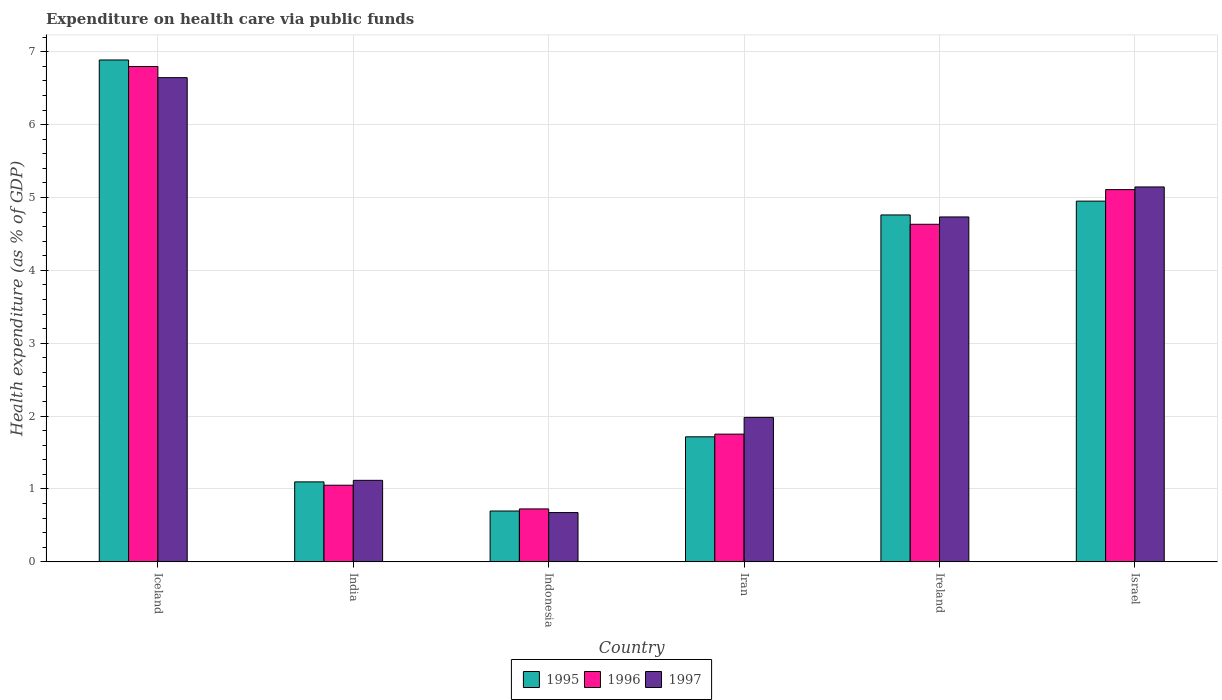How many different coloured bars are there?
Your answer should be very brief. 3. How many groups of bars are there?
Provide a short and direct response. 6. Are the number of bars per tick equal to the number of legend labels?
Keep it short and to the point. Yes. Are the number of bars on each tick of the X-axis equal?
Make the answer very short. Yes. How many bars are there on the 2nd tick from the left?
Your answer should be compact. 3. How many bars are there on the 6th tick from the right?
Offer a very short reply. 3. What is the label of the 5th group of bars from the left?
Your answer should be very brief. Ireland. What is the expenditure made on health care in 1997 in India?
Keep it short and to the point. 1.12. Across all countries, what is the maximum expenditure made on health care in 1995?
Keep it short and to the point. 6.89. Across all countries, what is the minimum expenditure made on health care in 1997?
Ensure brevity in your answer.  0.68. In which country was the expenditure made on health care in 1996 maximum?
Your response must be concise. Iceland. In which country was the expenditure made on health care in 1995 minimum?
Make the answer very short. Indonesia. What is the total expenditure made on health care in 1995 in the graph?
Your answer should be very brief. 20.11. What is the difference between the expenditure made on health care in 1996 in India and that in Indonesia?
Provide a short and direct response. 0.33. What is the difference between the expenditure made on health care in 1996 in Ireland and the expenditure made on health care in 1995 in Indonesia?
Your answer should be very brief. 3.93. What is the average expenditure made on health care in 1997 per country?
Keep it short and to the point. 3.38. What is the difference between the expenditure made on health care of/in 1996 and expenditure made on health care of/in 1995 in Indonesia?
Your answer should be very brief. 0.03. In how many countries, is the expenditure made on health care in 1997 greater than 2.4 %?
Ensure brevity in your answer.  3. What is the ratio of the expenditure made on health care in 1997 in Iran to that in Ireland?
Make the answer very short. 0.42. What is the difference between the highest and the second highest expenditure made on health care in 1997?
Ensure brevity in your answer.  -0.41. What is the difference between the highest and the lowest expenditure made on health care in 1995?
Your answer should be very brief. 6.19. In how many countries, is the expenditure made on health care in 1997 greater than the average expenditure made on health care in 1997 taken over all countries?
Offer a very short reply. 3. Is the sum of the expenditure made on health care in 1995 in India and Indonesia greater than the maximum expenditure made on health care in 1997 across all countries?
Provide a short and direct response. No. Is it the case that in every country, the sum of the expenditure made on health care in 1995 and expenditure made on health care in 1996 is greater than the expenditure made on health care in 1997?
Your answer should be very brief. Yes. How many bars are there?
Make the answer very short. 18. How many countries are there in the graph?
Your answer should be very brief. 6. Are the values on the major ticks of Y-axis written in scientific E-notation?
Give a very brief answer. No. Does the graph contain any zero values?
Make the answer very short. No. Does the graph contain grids?
Make the answer very short. Yes. Where does the legend appear in the graph?
Provide a succinct answer. Bottom center. How are the legend labels stacked?
Your answer should be compact. Horizontal. What is the title of the graph?
Offer a terse response. Expenditure on health care via public funds. What is the label or title of the X-axis?
Make the answer very short. Country. What is the label or title of the Y-axis?
Give a very brief answer. Health expenditure (as % of GDP). What is the Health expenditure (as % of GDP) of 1995 in Iceland?
Offer a very short reply. 6.89. What is the Health expenditure (as % of GDP) of 1996 in Iceland?
Keep it short and to the point. 6.8. What is the Health expenditure (as % of GDP) in 1997 in Iceland?
Your answer should be very brief. 6.64. What is the Health expenditure (as % of GDP) of 1995 in India?
Keep it short and to the point. 1.1. What is the Health expenditure (as % of GDP) in 1996 in India?
Ensure brevity in your answer.  1.05. What is the Health expenditure (as % of GDP) of 1997 in India?
Provide a succinct answer. 1.12. What is the Health expenditure (as % of GDP) in 1995 in Indonesia?
Make the answer very short. 0.7. What is the Health expenditure (as % of GDP) of 1996 in Indonesia?
Provide a short and direct response. 0.73. What is the Health expenditure (as % of GDP) in 1997 in Indonesia?
Keep it short and to the point. 0.68. What is the Health expenditure (as % of GDP) in 1995 in Iran?
Your response must be concise. 1.72. What is the Health expenditure (as % of GDP) in 1996 in Iran?
Your answer should be compact. 1.75. What is the Health expenditure (as % of GDP) of 1997 in Iran?
Keep it short and to the point. 1.98. What is the Health expenditure (as % of GDP) of 1995 in Ireland?
Your answer should be very brief. 4.76. What is the Health expenditure (as % of GDP) of 1996 in Ireland?
Ensure brevity in your answer.  4.63. What is the Health expenditure (as % of GDP) in 1997 in Ireland?
Keep it short and to the point. 4.73. What is the Health expenditure (as % of GDP) in 1995 in Israel?
Make the answer very short. 4.95. What is the Health expenditure (as % of GDP) of 1996 in Israel?
Provide a short and direct response. 5.11. What is the Health expenditure (as % of GDP) of 1997 in Israel?
Your response must be concise. 5.14. Across all countries, what is the maximum Health expenditure (as % of GDP) of 1995?
Provide a short and direct response. 6.89. Across all countries, what is the maximum Health expenditure (as % of GDP) of 1996?
Provide a short and direct response. 6.8. Across all countries, what is the maximum Health expenditure (as % of GDP) of 1997?
Your answer should be very brief. 6.64. Across all countries, what is the minimum Health expenditure (as % of GDP) in 1995?
Offer a very short reply. 0.7. Across all countries, what is the minimum Health expenditure (as % of GDP) of 1996?
Provide a succinct answer. 0.73. Across all countries, what is the minimum Health expenditure (as % of GDP) of 1997?
Provide a short and direct response. 0.68. What is the total Health expenditure (as % of GDP) of 1995 in the graph?
Offer a terse response. 20.11. What is the total Health expenditure (as % of GDP) of 1996 in the graph?
Offer a terse response. 20.07. What is the total Health expenditure (as % of GDP) in 1997 in the graph?
Give a very brief answer. 20.3. What is the difference between the Health expenditure (as % of GDP) in 1995 in Iceland and that in India?
Keep it short and to the point. 5.79. What is the difference between the Health expenditure (as % of GDP) of 1996 in Iceland and that in India?
Offer a terse response. 5.75. What is the difference between the Health expenditure (as % of GDP) of 1997 in Iceland and that in India?
Your answer should be very brief. 5.53. What is the difference between the Health expenditure (as % of GDP) in 1995 in Iceland and that in Indonesia?
Ensure brevity in your answer.  6.19. What is the difference between the Health expenditure (as % of GDP) in 1996 in Iceland and that in Indonesia?
Give a very brief answer. 6.07. What is the difference between the Health expenditure (as % of GDP) in 1997 in Iceland and that in Indonesia?
Offer a terse response. 5.97. What is the difference between the Health expenditure (as % of GDP) in 1995 in Iceland and that in Iran?
Make the answer very short. 5.17. What is the difference between the Health expenditure (as % of GDP) in 1996 in Iceland and that in Iran?
Your answer should be very brief. 5.04. What is the difference between the Health expenditure (as % of GDP) in 1997 in Iceland and that in Iran?
Keep it short and to the point. 4.66. What is the difference between the Health expenditure (as % of GDP) of 1995 in Iceland and that in Ireland?
Keep it short and to the point. 2.13. What is the difference between the Health expenditure (as % of GDP) in 1996 in Iceland and that in Ireland?
Make the answer very short. 2.16. What is the difference between the Health expenditure (as % of GDP) in 1997 in Iceland and that in Ireland?
Make the answer very short. 1.91. What is the difference between the Health expenditure (as % of GDP) in 1995 in Iceland and that in Israel?
Keep it short and to the point. 1.94. What is the difference between the Health expenditure (as % of GDP) of 1996 in Iceland and that in Israel?
Keep it short and to the point. 1.69. What is the difference between the Health expenditure (as % of GDP) of 1997 in Iceland and that in Israel?
Provide a short and direct response. 1.5. What is the difference between the Health expenditure (as % of GDP) of 1995 in India and that in Indonesia?
Your answer should be compact. 0.4. What is the difference between the Health expenditure (as % of GDP) in 1996 in India and that in Indonesia?
Offer a very short reply. 0.33. What is the difference between the Health expenditure (as % of GDP) in 1997 in India and that in Indonesia?
Ensure brevity in your answer.  0.44. What is the difference between the Health expenditure (as % of GDP) of 1995 in India and that in Iran?
Make the answer very short. -0.62. What is the difference between the Health expenditure (as % of GDP) of 1996 in India and that in Iran?
Provide a short and direct response. -0.7. What is the difference between the Health expenditure (as % of GDP) of 1997 in India and that in Iran?
Offer a terse response. -0.86. What is the difference between the Health expenditure (as % of GDP) in 1995 in India and that in Ireland?
Give a very brief answer. -3.66. What is the difference between the Health expenditure (as % of GDP) in 1996 in India and that in Ireland?
Offer a very short reply. -3.58. What is the difference between the Health expenditure (as % of GDP) of 1997 in India and that in Ireland?
Provide a succinct answer. -3.61. What is the difference between the Health expenditure (as % of GDP) of 1995 in India and that in Israel?
Offer a very short reply. -3.85. What is the difference between the Health expenditure (as % of GDP) in 1996 in India and that in Israel?
Give a very brief answer. -4.06. What is the difference between the Health expenditure (as % of GDP) in 1997 in India and that in Israel?
Offer a terse response. -4.03. What is the difference between the Health expenditure (as % of GDP) in 1995 in Indonesia and that in Iran?
Keep it short and to the point. -1.02. What is the difference between the Health expenditure (as % of GDP) of 1996 in Indonesia and that in Iran?
Offer a terse response. -1.03. What is the difference between the Health expenditure (as % of GDP) of 1997 in Indonesia and that in Iran?
Provide a succinct answer. -1.31. What is the difference between the Health expenditure (as % of GDP) in 1995 in Indonesia and that in Ireland?
Give a very brief answer. -4.06. What is the difference between the Health expenditure (as % of GDP) in 1996 in Indonesia and that in Ireland?
Your response must be concise. -3.91. What is the difference between the Health expenditure (as % of GDP) of 1997 in Indonesia and that in Ireland?
Your answer should be compact. -4.06. What is the difference between the Health expenditure (as % of GDP) of 1995 in Indonesia and that in Israel?
Provide a short and direct response. -4.25. What is the difference between the Health expenditure (as % of GDP) in 1996 in Indonesia and that in Israel?
Offer a very short reply. -4.38. What is the difference between the Health expenditure (as % of GDP) of 1997 in Indonesia and that in Israel?
Keep it short and to the point. -4.47. What is the difference between the Health expenditure (as % of GDP) in 1995 in Iran and that in Ireland?
Provide a short and direct response. -3.04. What is the difference between the Health expenditure (as % of GDP) of 1996 in Iran and that in Ireland?
Your response must be concise. -2.88. What is the difference between the Health expenditure (as % of GDP) in 1997 in Iran and that in Ireland?
Give a very brief answer. -2.75. What is the difference between the Health expenditure (as % of GDP) of 1995 in Iran and that in Israel?
Offer a terse response. -3.23. What is the difference between the Health expenditure (as % of GDP) in 1996 in Iran and that in Israel?
Keep it short and to the point. -3.36. What is the difference between the Health expenditure (as % of GDP) of 1997 in Iran and that in Israel?
Offer a very short reply. -3.16. What is the difference between the Health expenditure (as % of GDP) of 1995 in Ireland and that in Israel?
Provide a succinct answer. -0.19. What is the difference between the Health expenditure (as % of GDP) in 1996 in Ireland and that in Israel?
Your response must be concise. -0.48. What is the difference between the Health expenditure (as % of GDP) of 1997 in Ireland and that in Israel?
Offer a very short reply. -0.41. What is the difference between the Health expenditure (as % of GDP) in 1995 in Iceland and the Health expenditure (as % of GDP) in 1996 in India?
Your response must be concise. 5.84. What is the difference between the Health expenditure (as % of GDP) in 1995 in Iceland and the Health expenditure (as % of GDP) in 1997 in India?
Your response must be concise. 5.77. What is the difference between the Health expenditure (as % of GDP) of 1996 in Iceland and the Health expenditure (as % of GDP) of 1997 in India?
Your answer should be very brief. 5.68. What is the difference between the Health expenditure (as % of GDP) in 1995 in Iceland and the Health expenditure (as % of GDP) in 1996 in Indonesia?
Make the answer very short. 6.16. What is the difference between the Health expenditure (as % of GDP) of 1995 in Iceland and the Health expenditure (as % of GDP) of 1997 in Indonesia?
Give a very brief answer. 6.21. What is the difference between the Health expenditure (as % of GDP) in 1996 in Iceland and the Health expenditure (as % of GDP) in 1997 in Indonesia?
Offer a very short reply. 6.12. What is the difference between the Health expenditure (as % of GDP) of 1995 in Iceland and the Health expenditure (as % of GDP) of 1996 in Iran?
Your answer should be compact. 5.13. What is the difference between the Health expenditure (as % of GDP) in 1995 in Iceland and the Health expenditure (as % of GDP) in 1997 in Iran?
Provide a succinct answer. 4.9. What is the difference between the Health expenditure (as % of GDP) in 1996 in Iceland and the Health expenditure (as % of GDP) in 1997 in Iran?
Make the answer very short. 4.81. What is the difference between the Health expenditure (as % of GDP) in 1995 in Iceland and the Health expenditure (as % of GDP) in 1996 in Ireland?
Provide a succinct answer. 2.25. What is the difference between the Health expenditure (as % of GDP) in 1995 in Iceland and the Health expenditure (as % of GDP) in 1997 in Ireland?
Your answer should be very brief. 2.15. What is the difference between the Health expenditure (as % of GDP) of 1996 in Iceland and the Health expenditure (as % of GDP) of 1997 in Ireland?
Give a very brief answer. 2.06. What is the difference between the Health expenditure (as % of GDP) in 1995 in Iceland and the Health expenditure (as % of GDP) in 1996 in Israel?
Your answer should be very brief. 1.78. What is the difference between the Health expenditure (as % of GDP) of 1995 in Iceland and the Health expenditure (as % of GDP) of 1997 in Israel?
Offer a very short reply. 1.74. What is the difference between the Health expenditure (as % of GDP) of 1996 in Iceland and the Health expenditure (as % of GDP) of 1997 in Israel?
Your answer should be compact. 1.65. What is the difference between the Health expenditure (as % of GDP) in 1995 in India and the Health expenditure (as % of GDP) in 1996 in Indonesia?
Provide a succinct answer. 0.37. What is the difference between the Health expenditure (as % of GDP) in 1995 in India and the Health expenditure (as % of GDP) in 1997 in Indonesia?
Provide a succinct answer. 0.42. What is the difference between the Health expenditure (as % of GDP) of 1995 in India and the Health expenditure (as % of GDP) of 1996 in Iran?
Keep it short and to the point. -0.66. What is the difference between the Health expenditure (as % of GDP) of 1995 in India and the Health expenditure (as % of GDP) of 1997 in Iran?
Give a very brief answer. -0.89. What is the difference between the Health expenditure (as % of GDP) of 1996 in India and the Health expenditure (as % of GDP) of 1997 in Iran?
Offer a very short reply. -0.93. What is the difference between the Health expenditure (as % of GDP) of 1995 in India and the Health expenditure (as % of GDP) of 1996 in Ireland?
Give a very brief answer. -3.53. What is the difference between the Health expenditure (as % of GDP) in 1995 in India and the Health expenditure (as % of GDP) in 1997 in Ireland?
Provide a short and direct response. -3.64. What is the difference between the Health expenditure (as % of GDP) in 1996 in India and the Health expenditure (as % of GDP) in 1997 in Ireland?
Your response must be concise. -3.68. What is the difference between the Health expenditure (as % of GDP) in 1995 in India and the Health expenditure (as % of GDP) in 1996 in Israel?
Your answer should be very brief. -4.01. What is the difference between the Health expenditure (as % of GDP) of 1995 in India and the Health expenditure (as % of GDP) of 1997 in Israel?
Give a very brief answer. -4.05. What is the difference between the Health expenditure (as % of GDP) in 1996 in India and the Health expenditure (as % of GDP) in 1997 in Israel?
Ensure brevity in your answer.  -4.09. What is the difference between the Health expenditure (as % of GDP) in 1995 in Indonesia and the Health expenditure (as % of GDP) in 1996 in Iran?
Your response must be concise. -1.05. What is the difference between the Health expenditure (as % of GDP) in 1995 in Indonesia and the Health expenditure (as % of GDP) in 1997 in Iran?
Your response must be concise. -1.28. What is the difference between the Health expenditure (as % of GDP) of 1996 in Indonesia and the Health expenditure (as % of GDP) of 1997 in Iran?
Provide a short and direct response. -1.26. What is the difference between the Health expenditure (as % of GDP) of 1995 in Indonesia and the Health expenditure (as % of GDP) of 1996 in Ireland?
Offer a very short reply. -3.93. What is the difference between the Health expenditure (as % of GDP) in 1995 in Indonesia and the Health expenditure (as % of GDP) in 1997 in Ireland?
Ensure brevity in your answer.  -4.04. What is the difference between the Health expenditure (as % of GDP) in 1996 in Indonesia and the Health expenditure (as % of GDP) in 1997 in Ireland?
Offer a terse response. -4.01. What is the difference between the Health expenditure (as % of GDP) of 1995 in Indonesia and the Health expenditure (as % of GDP) of 1996 in Israel?
Give a very brief answer. -4.41. What is the difference between the Health expenditure (as % of GDP) in 1995 in Indonesia and the Health expenditure (as % of GDP) in 1997 in Israel?
Give a very brief answer. -4.45. What is the difference between the Health expenditure (as % of GDP) of 1996 in Indonesia and the Health expenditure (as % of GDP) of 1997 in Israel?
Your response must be concise. -4.42. What is the difference between the Health expenditure (as % of GDP) in 1995 in Iran and the Health expenditure (as % of GDP) in 1996 in Ireland?
Make the answer very short. -2.92. What is the difference between the Health expenditure (as % of GDP) of 1995 in Iran and the Health expenditure (as % of GDP) of 1997 in Ireland?
Your response must be concise. -3.02. What is the difference between the Health expenditure (as % of GDP) of 1996 in Iran and the Health expenditure (as % of GDP) of 1997 in Ireland?
Offer a terse response. -2.98. What is the difference between the Health expenditure (as % of GDP) in 1995 in Iran and the Health expenditure (as % of GDP) in 1996 in Israel?
Offer a very short reply. -3.39. What is the difference between the Health expenditure (as % of GDP) in 1995 in Iran and the Health expenditure (as % of GDP) in 1997 in Israel?
Offer a very short reply. -3.43. What is the difference between the Health expenditure (as % of GDP) of 1996 in Iran and the Health expenditure (as % of GDP) of 1997 in Israel?
Offer a very short reply. -3.39. What is the difference between the Health expenditure (as % of GDP) in 1995 in Ireland and the Health expenditure (as % of GDP) in 1996 in Israel?
Your answer should be very brief. -0.35. What is the difference between the Health expenditure (as % of GDP) of 1995 in Ireland and the Health expenditure (as % of GDP) of 1997 in Israel?
Offer a terse response. -0.38. What is the difference between the Health expenditure (as % of GDP) in 1996 in Ireland and the Health expenditure (as % of GDP) in 1997 in Israel?
Your answer should be very brief. -0.51. What is the average Health expenditure (as % of GDP) in 1995 per country?
Make the answer very short. 3.35. What is the average Health expenditure (as % of GDP) in 1996 per country?
Provide a short and direct response. 3.34. What is the average Health expenditure (as % of GDP) in 1997 per country?
Ensure brevity in your answer.  3.38. What is the difference between the Health expenditure (as % of GDP) of 1995 and Health expenditure (as % of GDP) of 1996 in Iceland?
Provide a succinct answer. 0.09. What is the difference between the Health expenditure (as % of GDP) of 1995 and Health expenditure (as % of GDP) of 1997 in Iceland?
Offer a very short reply. 0.24. What is the difference between the Health expenditure (as % of GDP) in 1996 and Health expenditure (as % of GDP) in 1997 in Iceland?
Offer a very short reply. 0.15. What is the difference between the Health expenditure (as % of GDP) in 1995 and Health expenditure (as % of GDP) in 1996 in India?
Provide a succinct answer. 0.05. What is the difference between the Health expenditure (as % of GDP) of 1995 and Health expenditure (as % of GDP) of 1997 in India?
Ensure brevity in your answer.  -0.02. What is the difference between the Health expenditure (as % of GDP) of 1996 and Health expenditure (as % of GDP) of 1997 in India?
Provide a short and direct response. -0.07. What is the difference between the Health expenditure (as % of GDP) in 1995 and Health expenditure (as % of GDP) in 1996 in Indonesia?
Your response must be concise. -0.03. What is the difference between the Health expenditure (as % of GDP) in 1995 and Health expenditure (as % of GDP) in 1997 in Indonesia?
Make the answer very short. 0.02. What is the difference between the Health expenditure (as % of GDP) of 1996 and Health expenditure (as % of GDP) of 1997 in Indonesia?
Offer a terse response. 0.05. What is the difference between the Health expenditure (as % of GDP) in 1995 and Health expenditure (as % of GDP) in 1996 in Iran?
Provide a short and direct response. -0.04. What is the difference between the Health expenditure (as % of GDP) of 1995 and Health expenditure (as % of GDP) of 1997 in Iran?
Give a very brief answer. -0.27. What is the difference between the Health expenditure (as % of GDP) of 1996 and Health expenditure (as % of GDP) of 1997 in Iran?
Your answer should be compact. -0.23. What is the difference between the Health expenditure (as % of GDP) of 1995 and Health expenditure (as % of GDP) of 1996 in Ireland?
Ensure brevity in your answer.  0.13. What is the difference between the Health expenditure (as % of GDP) of 1995 and Health expenditure (as % of GDP) of 1997 in Ireland?
Your response must be concise. 0.03. What is the difference between the Health expenditure (as % of GDP) of 1996 and Health expenditure (as % of GDP) of 1997 in Ireland?
Keep it short and to the point. -0.1. What is the difference between the Health expenditure (as % of GDP) in 1995 and Health expenditure (as % of GDP) in 1996 in Israel?
Provide a short and direct response. -0.16. What is the difference between the Health expenditure (as % of GDP) of 1995 and Health expenditure (as % of GDP) of 1997 in Israel?
Offer a very short reply. -0.19. What is the difference between the Health expenditure (as % of GDP) in 1996 and Health expenditure (as % of GDP) in 1997 in Israel?
Offer a very short reply. -0.04. What is the ratio of the Health expenditure (as % of GDP) in 1995 in Iceland to that in India?
Provide a succinct answer. 6.27. What is the ratio of the Health expenditure (as % of GDP) in 1996 in Iceland to that in India?
Make the answer very short. 6.46. What is the ratio of the Health expenditure (as % of GDP) in 1997 in Iceland to that in India?
Offer a terse response. 5.94. What is the ratio of the Health expenditure (as % of GDP) in 1995 in Iceland to that in Indonesia?
Give a very brief answer. 9.87. What is the ratio of the Health expenditure (as % of GDP) in 1996 in Iceland to that in Indonesia?
Your answer should be very brief. 9.35. What is the ratio of the Health expenditure (as % of GDP) of 1997 in Iceland to that in Indonesia?
Make the answer very short. 9.82. What is the ratio of the Health expenditure (as % of GDP) in 1995 in Iceland to that in Iran?
Make the answer very short. 4.01. What is the ratio of the Health expenditure (as % of GDP) of 1996 in Iceland to that in Iran?
Give a very brief answer. 3.88. What is the ratio of the Health expenditure (as % of GDP) of 1997 in Iceland to that in Iran?
Ensure brevity in your answer.  3.35. What is the ratio of the Health expenditure (as % of GDP) in 1995 in Iceland to that in Ireland?
Offer a terse response. 1.45. What is the ratio of the Health expenditure (as % of GDP) of 1996 in Iceland to that in Ireland?
Your answer should be compact. 1.47. What is the ratio of the Health expenditure (as % of GDP) of 1997 in Iceland to that in Ireland?
Your answer should be very brief. 1.4. What is the ratio of the Health expenditure (as % of GDP) of 1995 in Iceland to that in Israel?
Offer a terse response. 1.39. What is the ratio of the Health expenditure (as % of GDP) of 1996 in Iceland to that in Israel?
Make the answer very short. 1.33. What is the ratio of the Health expenditure (as % of GDP) in 1997 in Iceland to that in Israel?
Make the answer very short. 1.29. What is the ratio of the Health expenditure (as % of GDP) of 1995 in India to that in Indonesia?
Your answer should be very brief. 1.57. What is the ratio of the Health expenditure (as % of GDP) in 1996 in India to that in Indonesia?
Keep it short and to the point. 1.45. What is the ratio of the Health expenditure (as % of GDP) of 1997 in India to that in Indonesia?
Offer a very short reply. 1.65. What is the ratio of the Health expenditure (as % of GDP) of 1995 in India to that in Iran?
Your answer should be compact. 0.64. What is the ratio of the Health expenditure (as % of GDP) of 1996 in India to that in Iran?
Provide a short and direct response. 0.6. What is the ratio of the Health expenditure (as % of GDP) in 1997 in India to that in Iran?
Offer a very short reply. 0.56. What is the ratio of the Health expenditure (as % of GDP) of 1995 in India to that in Ireland?
Provide a succinct answer. 0.23. What is the ratio of the Health expenditure (as % of GDP) of 1996 in India to that in Ireland?
Make the answer very short. 0.23. What is the ratio of the Health expenditure (as % of GDP) of 1997 in India to that in Ireland?
Provide a succinct answer. 0.24. What is the ratio of the Health expenditure (as % of GDP) of 1995 in India to that in Israel?
Provide a succinct answer. 0.22. What is the ratio of the Health expenditure (as % of GDP) in 1996 in India to that in Israel?
Offer a terse response. 0.21. What is the ratio of the Health expenditure (as % of GDP) in 1997 in India to that in Israel?
Offer a very short reply. 0.22. What is the ratio of the Health expenditure (as % of GDP) of 1995 in Indonesia to that in Iran?
Provide a short and direct response. 0.41. What is the ratio of the Health expenditure (as % of GDP) of 1996 in Indonesia to that in Iran?
Give a very brief answer. 0.41. What is the ratio of the Health expenditure (as % of GDP) in 1997 in Indonesia to that in Iran?
Your answer should be very brief. 0.34. What is the ratio of the Health expenditure (as % of GDP) in 1995 in Indonesia to that in Ireland?
Keep it short and to the point. 0.15. What is the ratio of the Health expenditure (as % of GDP) in 1996 in Indonesia to that in Ireland?
Ensure brevity in your answer.  0.16. What is the ratio of the Health expenditure (as % of GDP) in 1997 in Indonesia to that in Ireland?
Your response must be concise. 0.14. What is the ratio of the Health expenditure (as % of GDP) in 1995 in Indonesia to that in Israel?
Offer a very short reply. 0.14. What is the ratio of the Health expenditure (as % of GDP) of 1996 in Indonesia to that in Israel?
Give a very brief answer. 0.14. What is the ratio of the Health expenditure (as % of GDP) of 1997 in Indonesia to that in Israel?
Offer a terse response. 0.13. What is the ratio of the Health expenditure (as % of GDP) of 1995 in Iran to that in Ireland?
Your response must be concise. 0.36. What is the ratio of the Health expenditure (as % of GDP) of 1996 in Iran to that in Ireland?
Keep it short and to the point. 0.38. What is the ratio of the Health expenditure (as % of GDP) of 1997 in Iran to that in Ireland?
Offer a very short reply. 0.42. What is the ratio of the Health expenditure (as % of GDP) in 1995 in Iran to that in Israel?
Offer a terse response. 0.35. What is the ratio of the Health expenditure (as % of GDP) in 1996 in Iran to that in Israel?
Ensure brevity in your answer.  0.34. What is the ratio of the Health expenditure (as % of GDP) in 1997 in Iran to that in Israel?
Keep it short and to the point. 0.39. What is the ratio of the Health expenditure (as % of GDP) of 1995 in Ireland to that in Israel?
Your answer should be compact. 0.96. What is the ratio of the Health expenditure (as % of GDP) in 1996 in Ireland to that in Israel?
Provide a short and direct response. 0.91. What is the ratio of the Health expenditure (as % of GDP) in 1997 in Ireland to that in Israel?
Your answer should be compact. 0.92. What is the difference between the highest and the second highest Health expenditure (as % of GDP) of 1995?
Offer a very short reply. 1.94. What is the difference between the highest and the second highest Health expenditure (as % of GDP) of 1996?
Provide a succinct answer. 1.69. What is the difference between the highest and the second highest Health expenditure (as % of GDP) in 1997?
Give a very brief answer. 1.5. What is the difference between the highest and the lowest Health expenditure (as % of GDP) in 1995?
Provide a succinct answer. 6.19. What is the difference between the highest and the lowest Health expenditure (as % of GDP) in 1996?
Provide a succinct answer. 6.07. What is the difference between the highest and the lowest Health expenditure (as % of GDP) of 1997?
Your answer should be very brief. 5.97. 